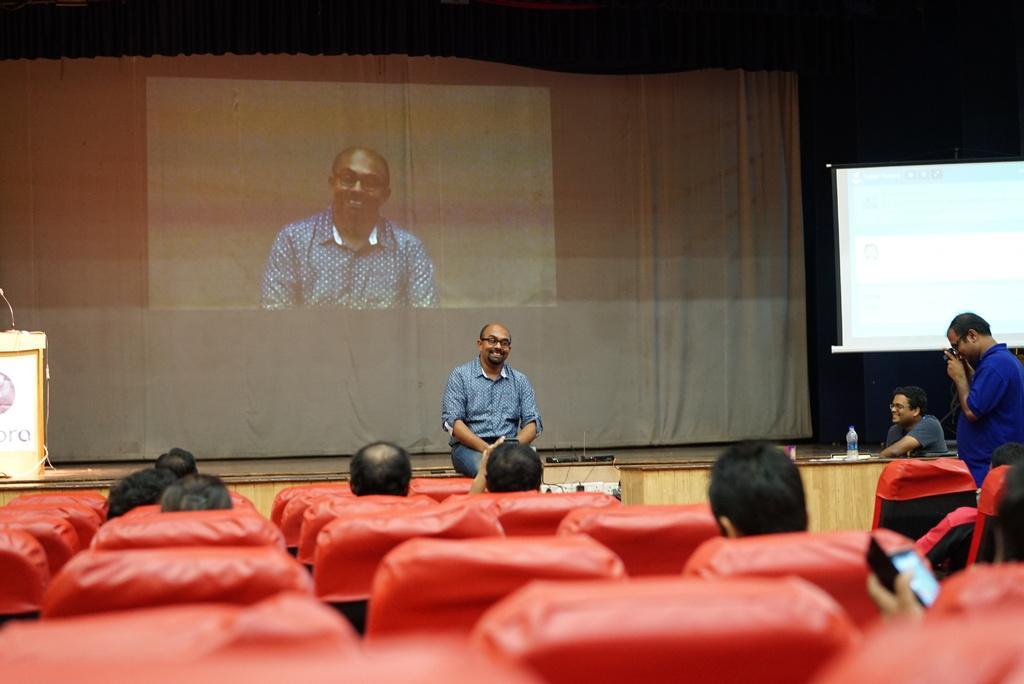How would you summarize this image in a sentence or two? In the middle a man is sitting and speaking, he wore shirt, trouser. Behind him there is a projector screen, on the right side a man is standing, he wore blue color shirt. 